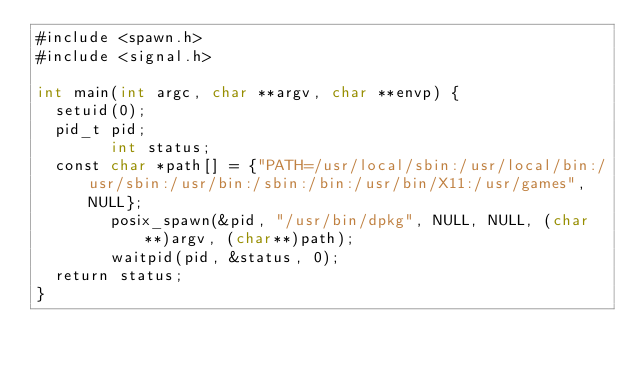<code> <loc_0><loc_0><loc_500><loc_500><_ObjectiveC_>#include <spawn.h>
#include <signal.h>

int main(int argc, char **argv, char **envp) {
	setuid(0);
	pid_t pid;
        int status;
	const char *path[] = {"PATH=/usr/local/sbin:/usr/local/bin:/usr/sbin:/usr/bin:/sbin:/bin:/usr/bin/X11:/usr/games", NULL};
        posix_spawn(&pid, "/usr/bin/dpkg", NULL, NULL, (char**)argv, (char**)path);
        waitpid(pid, &status, 0);
	return status;
}
</code> 